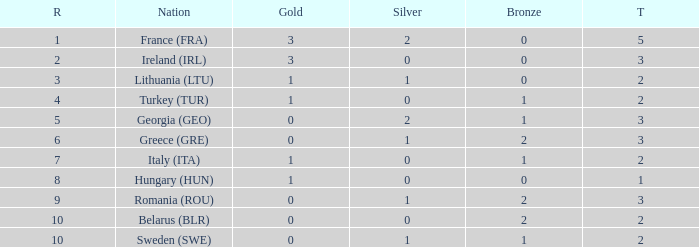What's the total of rank 8 when Silver medals are 0 and gold is more than 1? 0.0. 